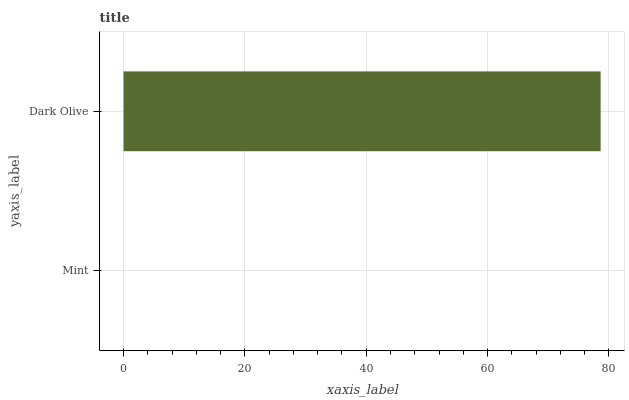Is Mint the minimum?
Answer yes or no. Yes. Is Dark Olive the maximum?
Answer yes or no. Yes. Is Dark Olive the minimum?
Answer yes or no. No. Is Dark Olive greater than Mint?
Answer yes or no. Yes. Is Mint less than Dark Olive?
Answer yes or no. Yes. Is Mint greater than Dark Olive?
Answer yes or no. No. Is Dark Olive less than Mint?
Answer yes or no. No. Is Dark Olive the high median?
Answer yes or no. Yes. Is Mint the low median?
Answer yes or no. Yes. Is Mint the high median?
Answer yes or no. No. Is Dark Olive the low median?
Answer yes or no. No. 